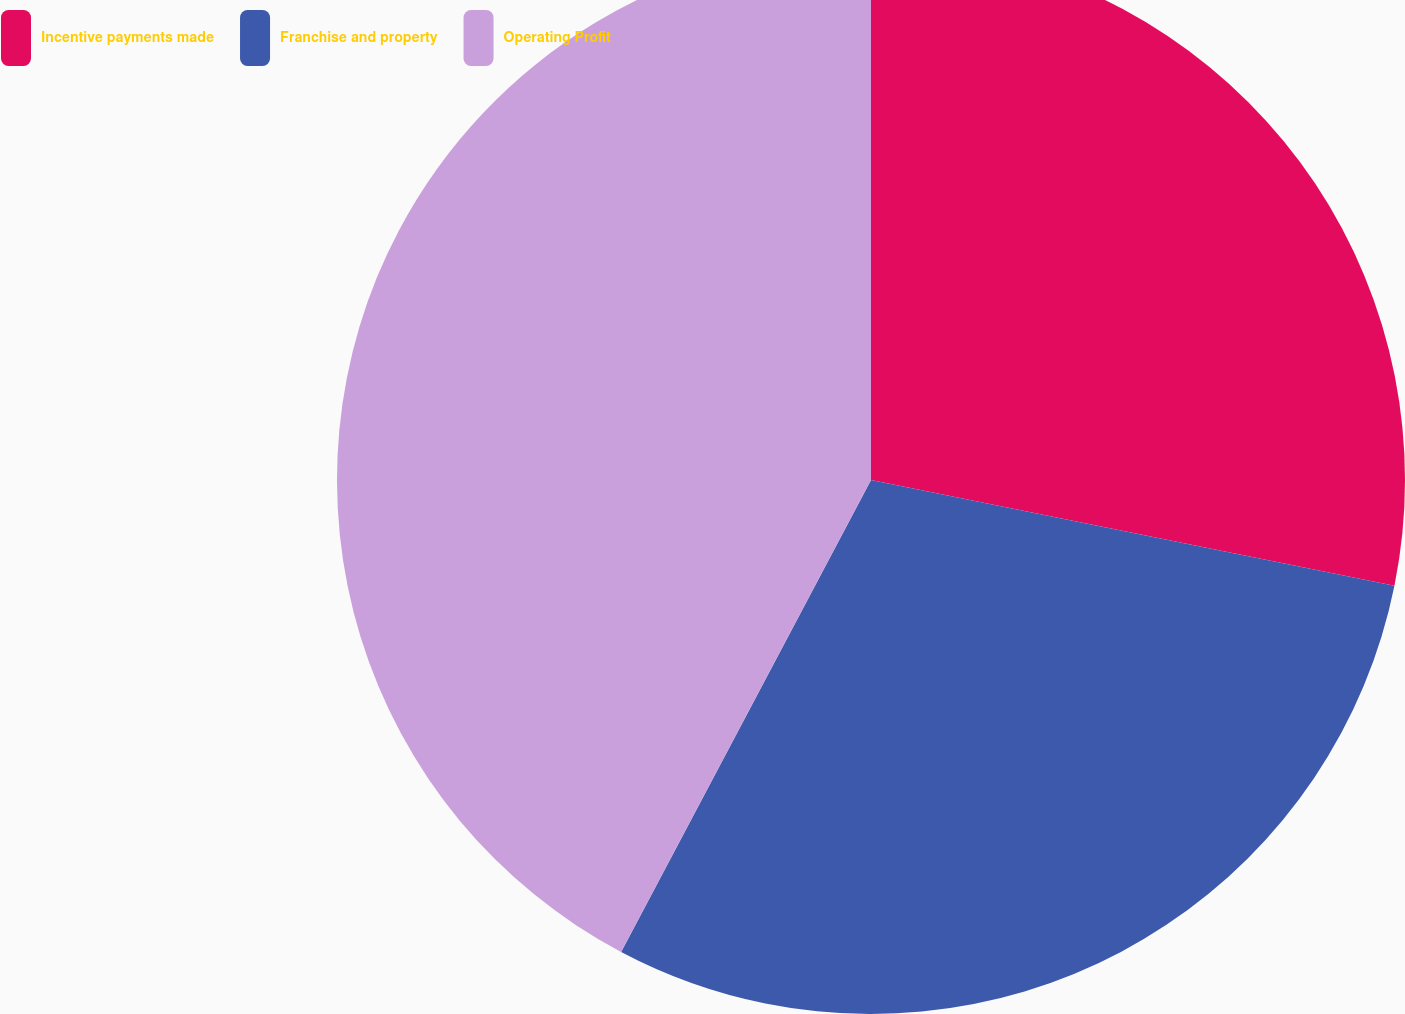<chart> <loc_0><loc_0><loc_500><loc_500><pie_chart><fcel>Incentive payments made<fcel>Franchise and property<fcel>Operating Profit<nl><fcel>28.17%<fcel>29.58%<fcel>42.25%<nl></chart> 